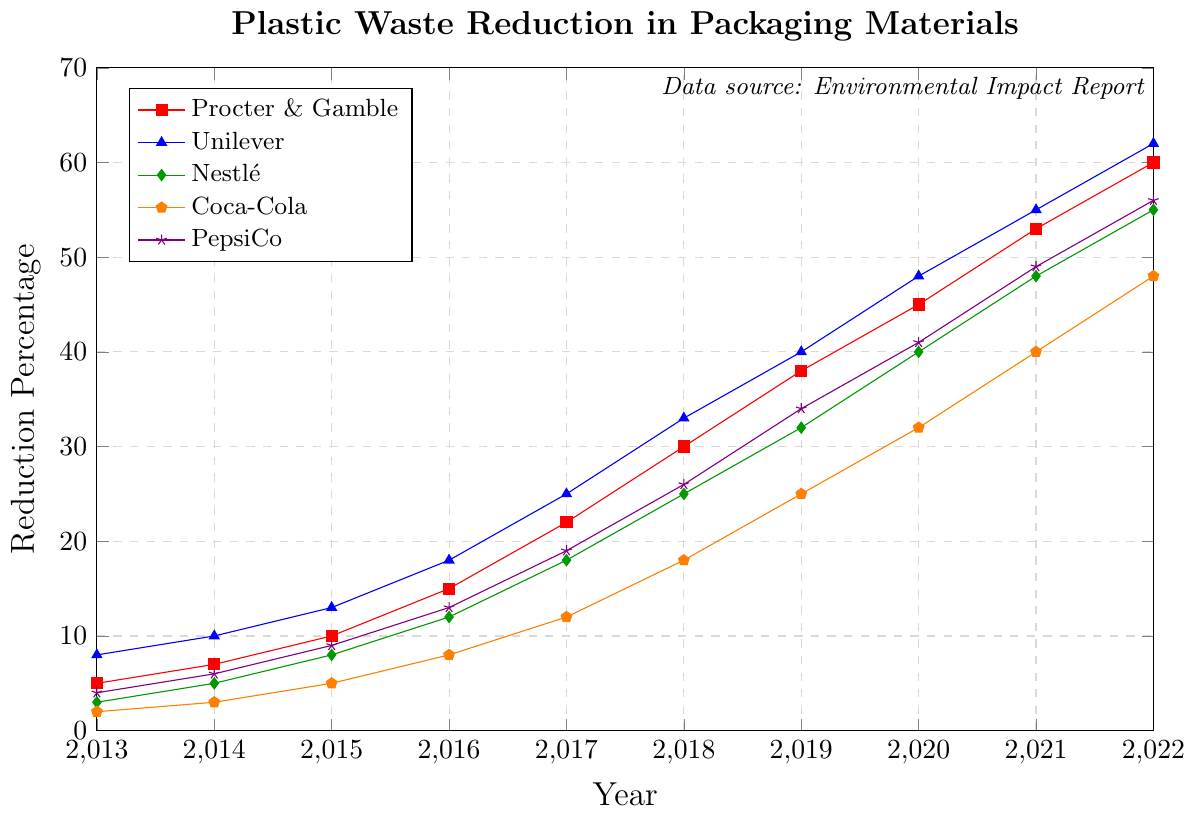How did Plastic Waste Reduction in Packaging Materials change for Procter & Gamble from 2013 to 2022? To determine the change in reduction percentage for Procter & Gamble, subtract the 2013 value (5%) from the 2022 value (60%). The change is 60% - 5% = 55%.
Answer: 55% Which company had the highest reduction percentage in 2022 and what was it? By looking at the data points for 2022, Unilever had the highest reduction percentage at 62%.
Answer: Unilever, 62% What was the difference in the reduction percentage between Coca-Cola and PepsiCo in 2018? According to the data for 2018, Coca-Cola had a reduction percentage of 18% and PepsiCo had 26%. The difference is 26% - 18% = 8%.
Answer: 8% On average, how much did Nestlé's reduction percentage increase per year from 2013 to 2022? The increase in reduction percentage for Nestlé from 2013 to 2022 is 55% - 3% = 52%. There are 9 intervals between these years (2022-2013). The average increase per year is 52% / 9 ≈ 5.78%.
Answer: 5.78% In which year did Procter & Gamble surpass a 50% reduction in plastic waste for the first time, and what was the exact percentage reduction that year? Procter & Gamble surpassed a 50% reduction in 2021 with an exact reduction percentage of 53%.
Answer: 2021, 53% How does the CAGR (Compound Annual Growth Rate) of Unilever's reduction percentage compare to that of PepsiCo over the decade? The CAGR can be calculated using the formula: CAGR = (Ending Value/Beginning Value)^(1/number of years) - 1. For Unilever, the CAGR from 8% to 62% over 9 years is ((62/8)^(1/9) - 1) ≈ 22.55%. For PepsiCo, from 4% to 56%, it is ((56/4)^(1/9) - 1) ≈ 29.61%. Therefore, PepsiCo's CAGR is higher.
Answer: PepsiCo's CAGR is higher Between which consecutive years did Coca-Cola see the largest single-year increase in reduction percentage, and what was the increase? By examining the year-to-year changes for Coca-Cola: 
2014 - 2013 = 1%, 
2015 - 2014 = 2%, 
2016 - 2015 = 3%, 
2017 - 2016 = 4%, 
2018 - 2017 = 6%, 
2019 - 2018 = 7%, 
2020 - 2019 = 7%, 
2021 - 2020 = 8%, 
2022 - 2021 = 8%. The largest increase was between 2020 and 2021 and 2021 and 2022, both with an increase of 8%.
Answer: 2020-2021 and 2021-2022, 8% Which company consistently had the smallest reduction percentage in plastic waste over the decade? Viewing the reduction percentages for all companies over the decade, Coca-Cola consistently had the smallest reduction percentages year over year compared to the other companies.
Answer: Coca-Cola How much more did Unilever reduce its plastic waste compared to Procter & Gamble in 2017? In 2017, Unilever had a reduction percentage of 25% and Procter & Gamble had 22%. The difference is 25% - 22% = 3%.
Answer: 3% Using only the plot, in what visual way can you tell which company's reduction efforts were more aggressive over time? The steepness of the lines indicates how aggressively reduction efforts were pursued. Unilever's line is the steepest, indicating the most aggressive reduction efforts over time, followed by PepsiCo.
Answer: Steepness of Unilever's line 